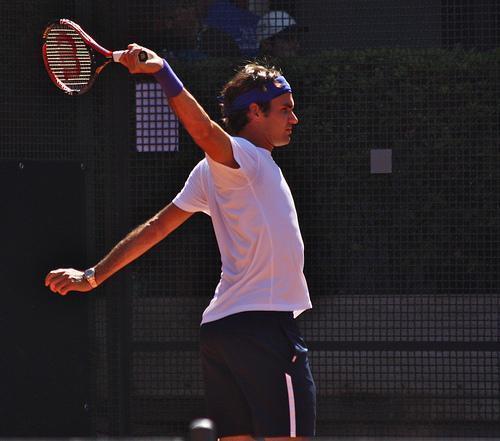How many rackets the man are holding?
Give a very brief answer. 1. 